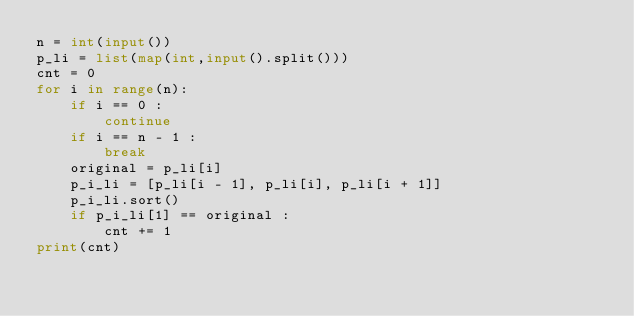<code> <loc_0><loc_0><loc_500><loc_500><_Python_>n = int(input())
p_li = list(map(int,input().split()))
cnt = 0
for i in range(n):
    if i == 0 :
        continue
    if i == n - 1 :
        break
    original = p_li[i]
    p_i_li = [p_li[i - 1], p_li[i], p_li[i + 1]]
    p_i_li.sort()
    if p_i_li[1] == original :
        cnt += 1
print(cnt)
</code> 